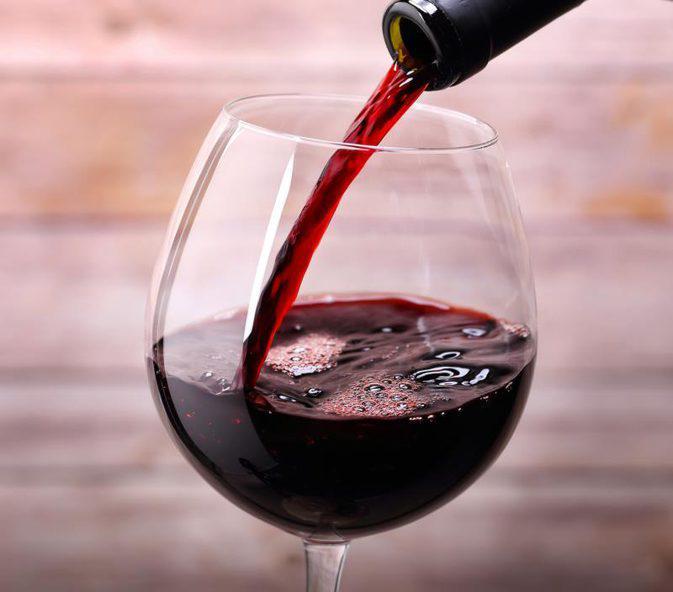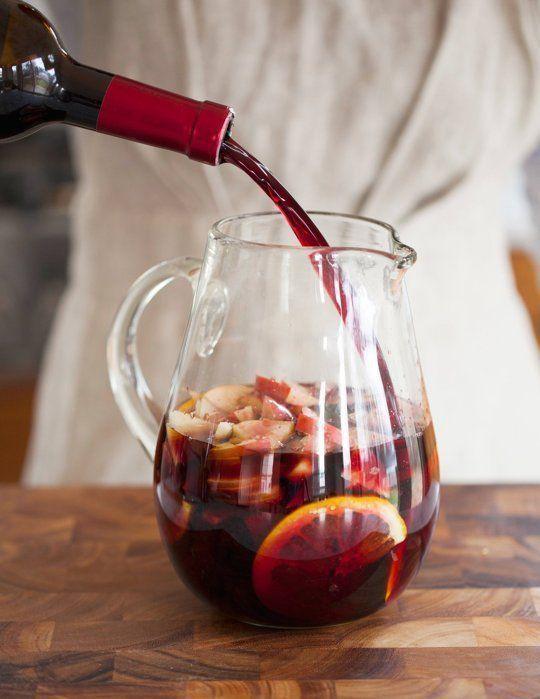The first image is the image on the left, the second image is the image on the right. Analyze the images presented: Is the assertion "Lime is used as a garnish in at least one image." valid? Answer yes or no. No. The first image is the image on the left, the second image is the image on the right. Considering the images on both sides, is "At least one image shows a beverage with a lime wedge as its garnish." valid? Answer yes or no. No. 